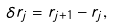<formula> <loc_0><loc_0><loc_500><loc_500>\delta { r } _ { j } = { r } _ { j + 1 } - { r } _ { j } ,</formula> 